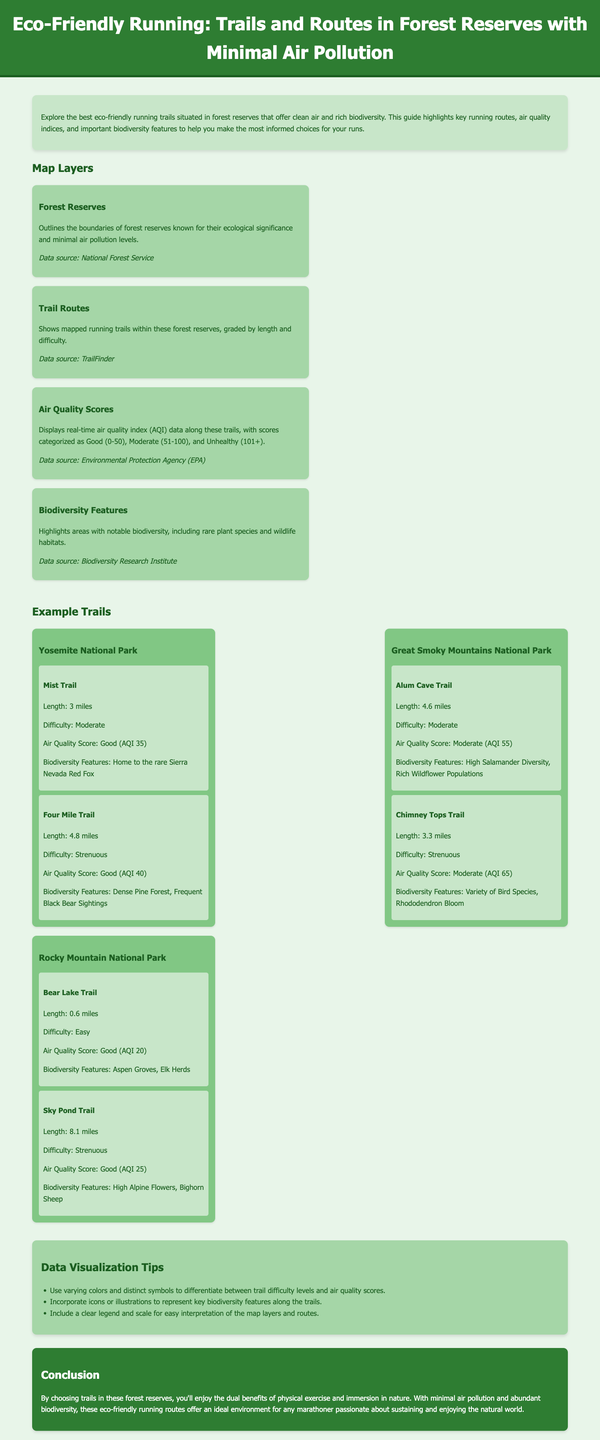what is the air quality score for Mist Trail? The air quality score for Mist Trail is provided in the example trails section of the document, which states that the score is Good (AQI 35).
Answer: Good (AQI 35) what is the length of Alum Cave Trail? The document lists the length of Alum Cave Trail in the example trails section, indicating it is 4.6 miles long.
Answer: 4.6 miles how many trails are mentioned for Rocky Mountain National Park? The document provides a specific count of trails in the examples for Rocky Mountain National Park, which includes two trails: Bear Lake Trail and Sky Pond Trail.
Answer: 2 which forest reserve features a population of Sierra Nevada Red Fox? The document mentions that Yosemite National Park is home to the rare Sierra Nevada Red Fox in the biodiversity features section.
Answer: Yosemite National Park what type of vegetation is highlighted along Bear Lake Trail? The biodiversity features for Bear Lake Trail indicate it has Aspen Groves, which signify the type of vegetation found there.
Answer: Aspen Groves which air quality category does Sky Pond Trail fall under? The document categorizes the air quality score for Sky Pond Trail, stating it is Good (AQI 25).
Answer: Good (AQI 25) what is a suggested tip for data visualization in the infographic? The document provides tips in the data visualization section, suggesting to incorporate icons or illustrations to represent key biodiversity features along the trails.
Answer: Incorporate icons or illustrations which hiking trail is described as Strenuous in Yosemite National Park? The example trails section lists Four Mile Trail as a Strenuous trail, indicating its difficulty level.
Answer: Four Mile Trail what color scheme is predominantly used for the background in the document? The document describes a background color scheme using light green hues, specifically #e8f5e9 for the body.
Answer: Light green 